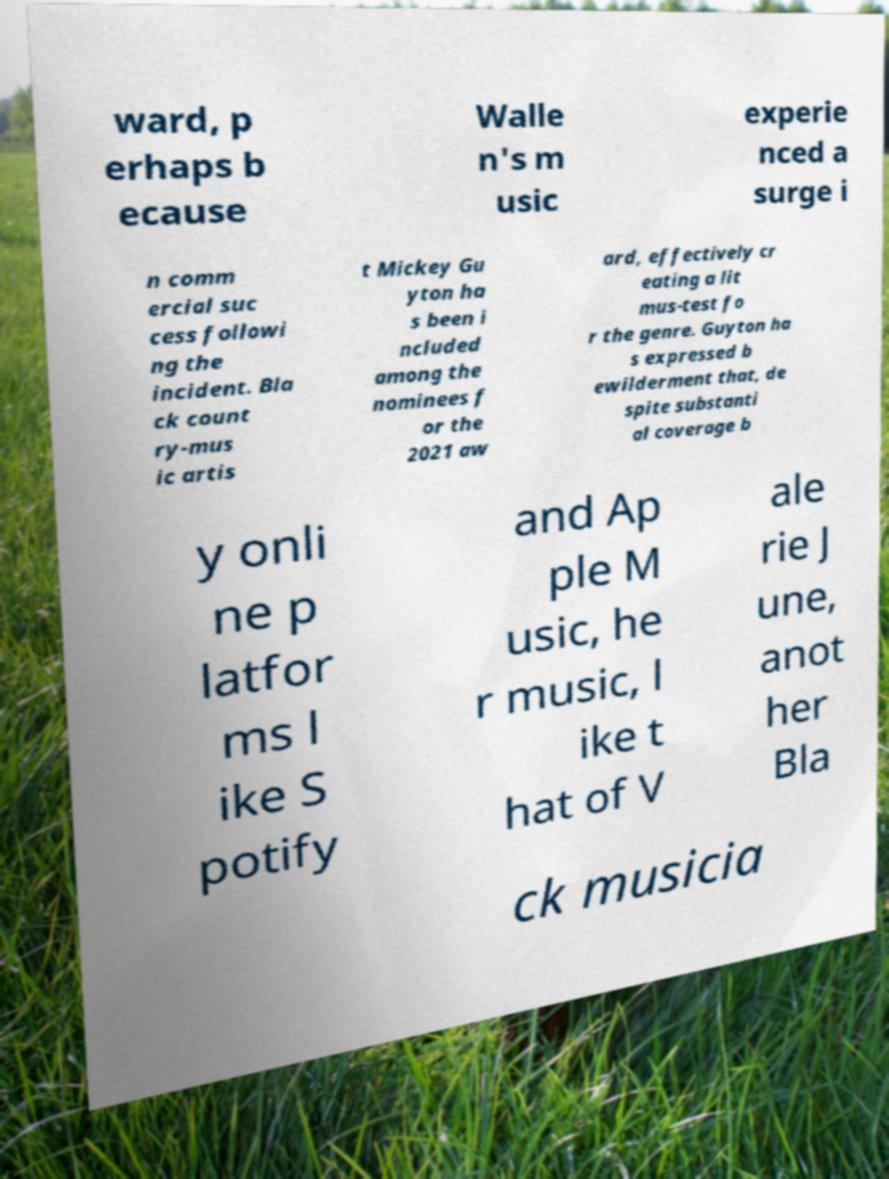I need the written content from this picture converted into text. Can you do that? ward, p erhaps b ecause Walle n's m usic experie nced a surge i n comm ercial suc cess followi ng the incident. Bla ck count ry-mus ic artis t Mickey Gu yton ha s been i ncluded among the nominees f or the 2021 aw ard, effectively cr eating a lit mus-test fo r the genre. Guyton ha s expressed b ewilderment that, de spite substanti al coverage b y onli ne p latfor ms l ike S potify and Ap ple M usic, he r music, l ike t hat of V ale rie J une, anot her Bla ck musicia 